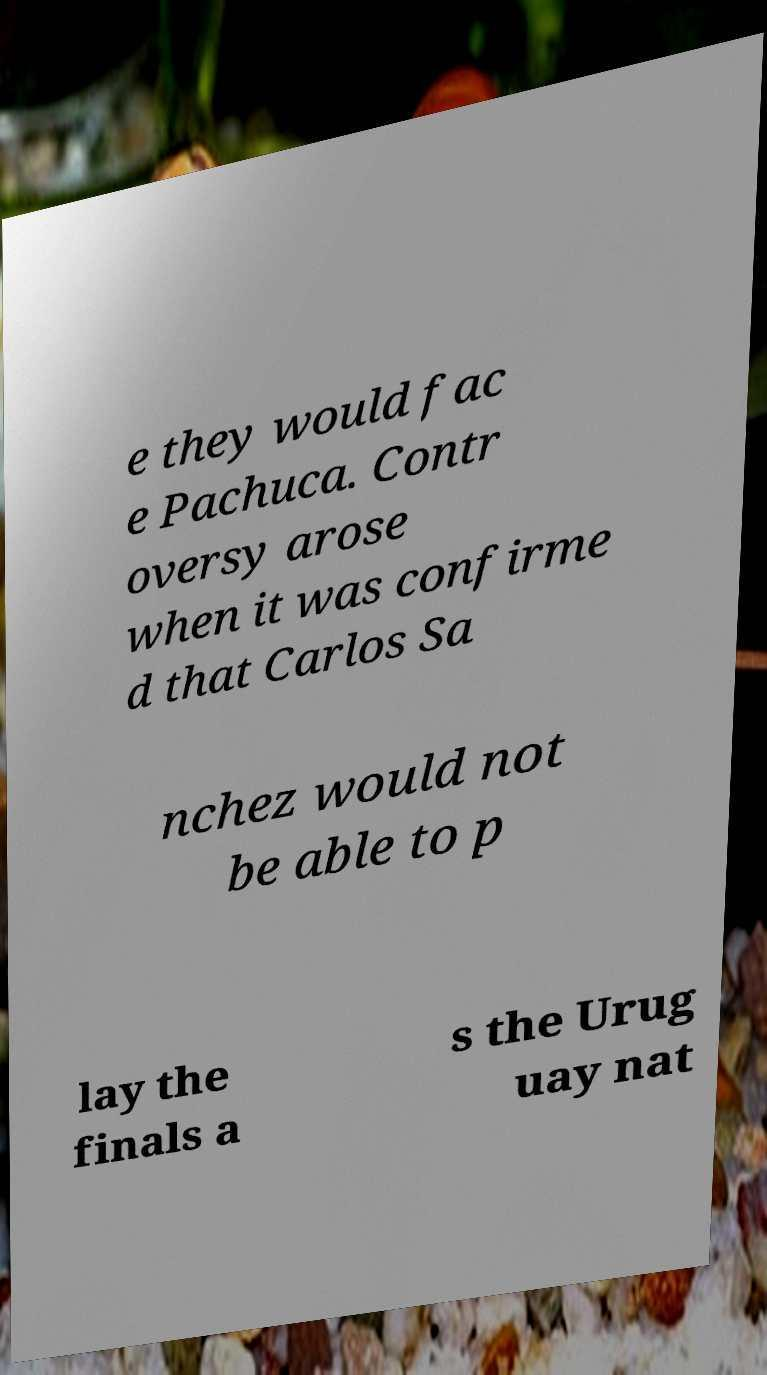Could you extract and type out the text from this image? e they would fac e Pachuca. Contr oversy arose when it was confirme d that Carlos Sa nchez would not be able to p lay the finals a s the Urug uay nat 